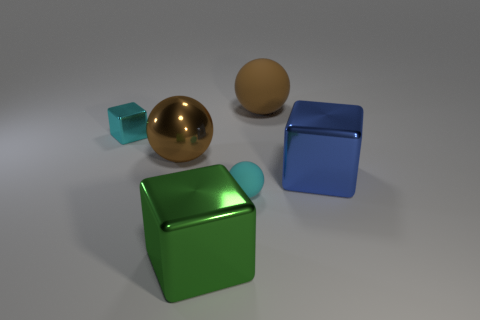Is there any indication about the light source in this image? The soft shadows cast on the ground and the reflective highlights on the objects suggest the presence of a diffuse overhead light source, likely out of the frame. 